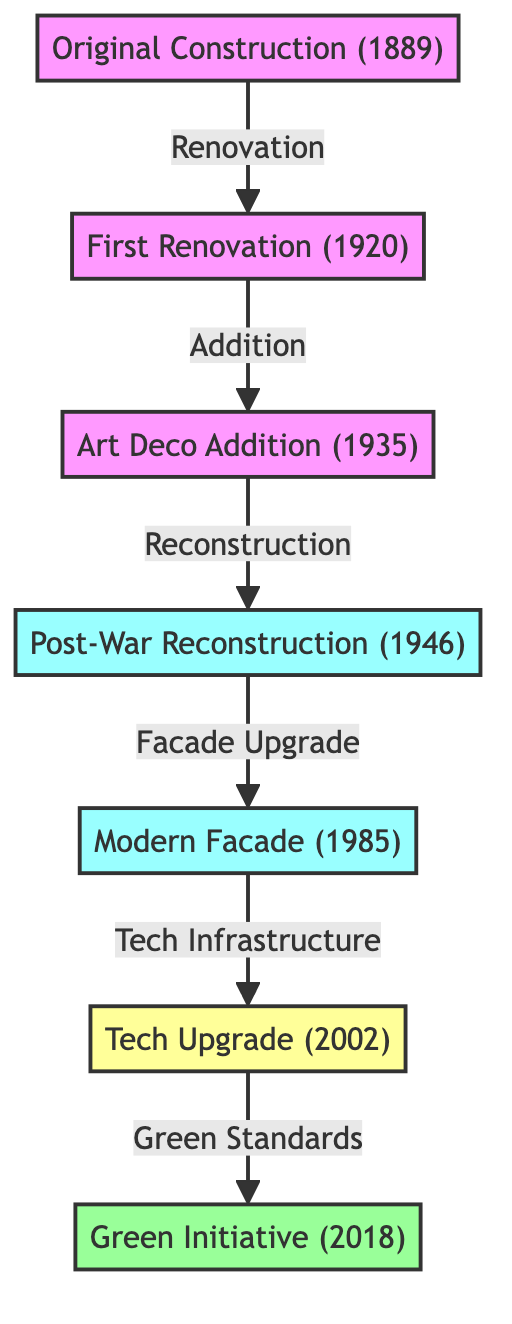What year did the building undergo its first major renovation? The diagram indicates that the first major renovation occurred in 1920, as labeled in the "First Renovation" node.
Answer: 1920 What is the relationship between the "First Renovation" and the "Art Deco Addition"? The diagram shows an arrow labeled "Addition" connecting the "First Renovation" node to the "Art Deco Addition" node, indicating that the Art Deco wing was added after the first renovation.
Answer: Addition How many total nodes are present in the diagram? The diagram has a total of seven nodes, which includes the original construction, first renovation, art deco addition, post-war reconstruction, modern facade, tech upgrade, and green initiative.
Answer: 7 What was added to the building in 1985? According to the diagram, the "Modern Facade" was added to the building in 1985, as indicated by the "Modern Facade" node.
Answer: Modern Facade What type of upgrade was made in 2002? The diagram specifies that in 2002, a "Tech Upgrade" was made to the building, reflecting improvements in the building's infrastructure with modern technology.
Answer: Tech Upgrade What major event led to the "Post-War Reconstruction" in 1946? The diagram highlights that the "Post-War Reconstruction" occurred after World War II, emphasizing the reconstruction efforts made in 1946 due to the impacts of the war.
Answer: World War II Which renovation led directly to the "Green Initiative" in 2018? The diagram indicates that the "Tech Upgrade" in 2002 directly led to the "Green Initiative" in 2018, showing a sequence of updates enhancing building standards.
Answer: Tech Upgrade What is the label associated with the edge from the "Post-War Reconstruction" to the "Modern Facade"? The edge connecting these two nodes is labeled "Facade Upgrade," which indicates the nature of the upgrade made to the building's facade.
Answer: Facade Upgrade What was the relationship between the "Art Deco Addition" and the "Post-War Reconstruction"? The relationship is labeled "Reconstruction," indicating that the post-war reconstruction efforts followed the addition of the Art Deco wing.
Answer: Reconstruction 